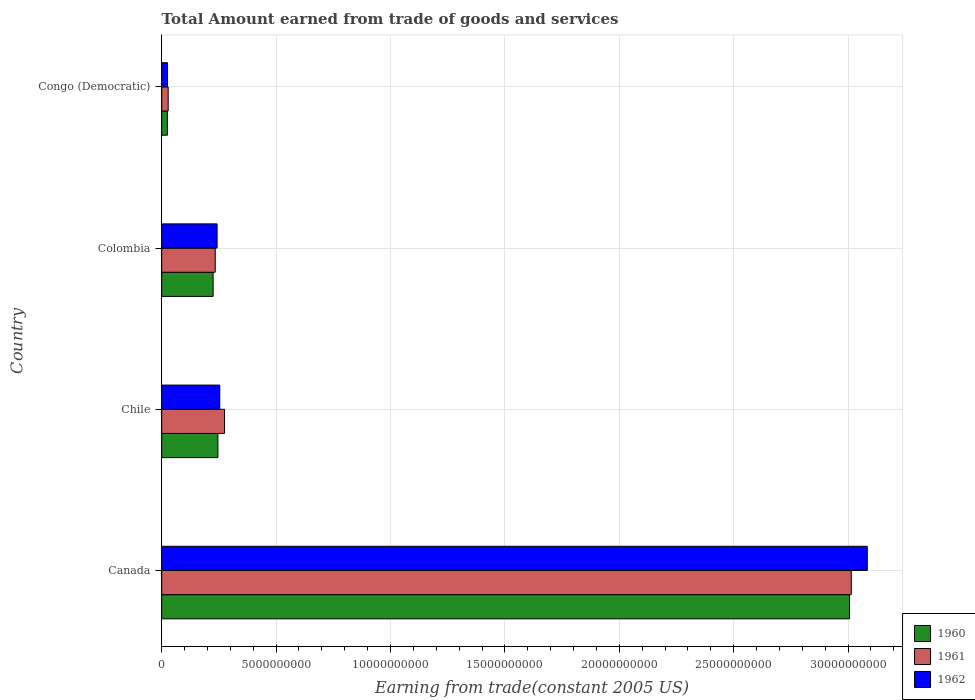Are the number of bars per tick equal to the number of legend labels?
Make the answer very short. Yes. How many bars are there on the 1st tick from the top?
Your response must be concise. 3. How many bars are there on the 2nd tick from the bottom?
Offer a very short reply. 3. In how many cases, is the number of bars for a given country not equal to the number of legend labels?
Give a very brief answer. 0. What is the total amount earned by trading goods and services in 1961 in Congo (Democratic)?
Offer a terse response. 2.83e+08. Across all countries, what is the maximum total amount earned by trading goods and services in 1960?
Your answer should be very brief. 3.01e+1. Across all countries, what is the minimum total amount earned by trading goods and services in 1961?
Keep it short and to the point. 2.83e+08. In which country was the total amount earned by trading goods and services in 1961 maximum?
Provide a succinct answer. Canada. In which country was the total amount earned by trading goods and services in 1962 minimum?
Keep it short and to the point. Congo (Democratic). What is the total total amount earned by trading goods and services in 1962 in the graph?
Offer a very short reply. 3.61e+1. What is the difference between the total amount earned by trading goods and services in 1960 in Colombia and that in Congo (Democratic)?
Offer a very short reply. 2.00e+09. What is the difference between the total amount earned by trading goods and services in 1961 in Chile and the total amount earned by trading goods and services in 1960 in Colombia?
Offer a terse response. 5.00e+08. What is the average total amount earned by trading goods and services in 1960 per country?
Provide a short and direct response. 8.75e+09. What is the difference between the total amount earned by trading goods and services in 1962 and total amount earned by trading goods and services in 1960 in Colombia?
Keep it short and to the point. 1.75e+08. What is the ratio of the total amount earned by trading goods and services in 1961 in Canada to that in Colombia?
Keep it short and to the point. 12.88. Is the difference between the total amount earned by trading goods and services in 1962 in Canada and Chile greater than the difference between the total amount earned by trading goods and services in 1960 in Canada and Chile?
Ensure brevity in your answer.  Yes. What is the difference between the highest and the second highest total amount earned by trading goods and services in 1961?
Offer a very short reply. 2.74e+1. What is the difference between the highest and the lowest total amount earned by trading goods and services in 1962?
Your answer should be very brief. 3.06e+1. What does the 2nd bar from the bottom in Colombia represents?
Offer a terse response. 1961. Is it the case that in every country, the sum of the total amount earned by trading goods and services in 1960 and total amount earned by trading goods and services in 1962 is greater than the total amount earned by trading goods and services in 1961?
Your answer should be compact. Yes. How many bars are there?
Make the answer very short. 12. Are all the bars in the graph horizontal?
Your answer should be very brief. Yes. How many countries are there in the graph?
Give a very brief answer. 4. Does the graph contain any zero values?
Ensure brevity in your answer.  No. Does the graph contain grids?
Provide a succinct answer. Yes. Where does the legend appear in the graph?
Keep it short and to the point. Bottom right. What is the title of the graph?
Offer a very short reply. Total Amount earned from trade of goods and services. Does "2006" appear as one of the legend labels in the graph?
Your response must be concise. No. What is the label or title of the X-axis?
Make the answer very short. Earning from trade(constant 2005 US). What is the Earning from trade(constant 2005 US) in 1960 in Canada?
Your answer should be compact. 3.01e+1. What is the Earning from trade(constant 2005 US) of 1961 in Canada?
Ensure brevity in your answer.  3.01e+1. What is the Earning from trade(constant 2005 US) of 1962 in Canada?
Keep it short and to the point. 3.08e+1. What is the Earning from trade(constant 2005 US) in 1960 in Chile?
Your answer should be compact. 2.46e+09. What is the Earning from trade(constant 2005 US) of 1961 in Chile?
Provide a short and direct response. 2.75e+09. What is the Earning from trade(constant 2005 US) in 1962 in Chile?
Make the answer very short. 2.54e+09. What is the Earning from trade(constant 2005 US) in 1960 in Colombia?
Your answer should be very brief. 2.25e+09. What is the Earning from trade(constant 2005 US) in 1961 in Colombia?
Offer a terse response. 2.34e+09. What is the Earning from trade(constant 2005 US) of 1962 in Colombia?
Provide a short and direct response. 2.42e+09. What is the Earning from trade(constant 2005 US) of 1960 in Congo (Democratic)?
Offer a terse response. 2.48e+08. What is the Earning from trade(constant 2005 US) of 1961 in Congo (Democratic)?
Ensure brevity in your answer.  2.83e+08. What is the Earning from trade(constant 2005 US) in 1962 in Congo (Democratic)?
Provide a succinct answer. 2.54e+08. Across all countries, what is the maximum Earning from trade(constant 2005 US) of 1960?
Your response must be concise. 3.01e+1. Across all countries, what is the maximum Earning from trade(constant 2005 US) of 1961?
Your answer should be compact. 3.01e+1. Across all countries, what is the maximum Earning from trade(constant 2005 US) in 1962?
Offer a terse response. 3.08e+1. Across all countries, what is the minimum Earning from trade(constant 2005 US) of 1960?
Offer a terse response. 2.48e+08. Across all countries, what is the minimum Earning from trade(constant 2005 US) of 1961?
Your answer should be very brief. 2.83e+08. Across all countries, what is the minimum Earning from trade(constant 2005 US) in 1962?
Make the answer very short. 2.54e+08. What is the total Earning from trade(constant 2005 US) in 1960 in the graph?
Offer a very short reply. 3.50e+1. What is the total Earning from trade(constant 2005 US) of 1961 in the graph?
Your response must be concise. 3.55e+1. What is the total Earning from trade(constant 2005 US) of 1962 in the graph?
Offer a very short reply. 3.61e+1. What is the difference between the Earning from trade(constant 2005 US) of 1960 in Canada and that in Chile?
Offer a very short reply. 2.76e+1. What is the difference between the Earning from trade(constant 2005 US) of 1961 in Canada and that in Chile?
Offer a terse response. 2.74e+1. What is the difference between the Earning from trade(constant 2005 US) in 1962 in Canada and that in Chile?
Give a very brief answer. 2.83e+1. What is the difference between the Earning from trade(constant 2005 US) in 1960 in Canada and that in Colombia?
Your response must be concise. 2.78e+1. What is the difference between the Earning from trade(constant 2005 US) of 1961 in Canada and that in Colombia?
Make the answer very short. 2.78e+1. What is the difference between the Earning from trade(constant 2005 US) of 1962 in Canada and that in Colombia?
Offer a very short reply. 2.84e+1. What is the difference between the Earning from trade(constant 2005 US) of 1960 in Canada and that in Congo (Democratic)?
Give a very brief answer. 2.98e+1. What is the difference between the Earning from trade(constant 2005 US) in 1961 in Canada and that in Congo (Democratic)?
Offer a very short reply. 2.99e+1. What is the difference between the Earning from trade(constant 2005 US) of 1962 in Canada and that in Congo (Democratic)?
Provide a succinct answer. 3.06e+1. What is the difference between the Earning from trade(constant 2005 US) of 1960 in Chile and that in Colombia?
Give a very brief answer. 2.10e+08. What is the difference between the Earning from trade(constant 2005 US) in 1961 in Chile and that in Colombia?
Keep it short and to the point. 4.07e+08. What is the difference between the Earning from trade(constant 2005 US) of 1962 in Chile and that in Colombia?
Provide a short and direct response. 1.17e+08. What is the difference between the Earning from trade(constant 2005 US) in 1960 in Chile and that in Congo (Democratic)?
Provide a succinct answer. 2.21e+09. What is the difference between the Earning from trade(constant 2005 US) of 1961 in Chile and that in Congo (Democratic)?
Offer a very short reply. 2.46e+09. What is the difference between the Earning from trade(constant 2005 US) in 1962 in Chile and that in Congo (Democratic)?
Ensure brevity in your answer.  2.28e+09. What is the difference between the Earning from trade(constant 2005 US) in 1960 in Colombia and that in Congo (Democratic)?
Offer a very short reply. 2.00e+09. What is the difference between the Earning from trade(constant 2005 US) of 1961 in Colombia and that in Congo (Democratic)?
Your answer should be compact. 2.06e+09. What is the difference between the Earning from trade(constant 2005 US) of 1962 in Colombia and that in Congo (Democratic)?
Your response must be concise. 2.17e+09. What is the difference between the Earning from trade(constant 2005 US) in 1960 in Canada and the Earning from trade(constant 2005 US) in 1961 in Chile?
Make the answer very short. 2.73e+1. What is the difference between the Earning from trade(constant 2005 US) in 1960 in Canada and the Earning from trade(constant 2005 US) in 1962 in Chile?
Provide a short and direct response. 2.75e+1. What is the difference between the Earning from trade(constant 2005 US) in 1961 in Canada and the Earning from trade(constant 2005 US) in 1962 in Chile?
Provide a succinct answer. 2.76e+1. What is the difference between the Earning from trade(constant 2005 US) in 1960 in Canada and the Earning from trade(constant 2005 US) in 1961 in Colombia?
Your answer should be very brief. 2.77e+1. What is the difference between the Earning from trade(constant 2005 US) of 1960 in Canada and the Earning from trade(constant 2005 US) of 1962 in Colombia?
Your answer should be very brief. 2.76e+1. What is the difference between the Earning from trade(constant 2005 US) of 1961 in Canada and the Earning from trade(constant 2005 US) of 1962 in Colombia?
Your answer should be very brief. 2.77e+1. What is the difference between the Earning from trade(constant 2005 US) in 1960 in Canada and the Earning from trade(constant 2005 US) in 1961 in Congo (Democratic)?
Your answer should be very brief. 2.98e+1. What is the difference between the Earning from trade(constant 2005 US) of 1960 in Canada and the Earning from trade(constant 2005 US) of 1962 in Congo (Democratic)?
Provide a succinct answer. 2.98e+1. What is the difference between the Earning from trade(constant 2005 US) of 1961 in Canada and the Earning from trade(constant 2005 US) of 1962 in Congo (Democratic)?
Your answer should be very brief. 2.99e+1. What is the difference between the Earning from trade(constant 2005 US) of 1960 in Chile and the Earning from trade(constant 2005 US) of 1961 in Colombia?
Your answer should be very brief. 1.17e+08. What is the difference between the Earning from trade(constant 2005 US) of 1960 in Chile and the Earning from trade(constant 2005 US) of 1962 in Colombia?
Your response must be concise. 3.52e+07. What is the difference between the Earning from trade(constant 2005 US) in 1961 in Chile and the Earning from trade(constant 2005 US) in 1962 in Colombia?
Your response must be concise. 3.25e+08. What is the difference between the Earning from trade(constant 2005 US) of 1960 in Chile and the Earning from trade(constant 2005 US) of 1961 in Congo (Democratic)?
Ensure brevity in your answer.  2.17e+09. What is the difference between the Earning from trade(constant 2005 US) in 1960 in Chile and the Earning from trade(constant 2005 US) in 1962 in Congo (Democratic)?
Offer a very short reply. 2.20e+09. What is the difference between the Earning from trade(constant 2005 US) in 1961 in Chile and the Earning from trade(constant 2005 US) in 1962 in Congo (Democratic)?
Provide a succinct answer. 2.49e+09. What is the difference between the Earning from trade(constant 2005 US) in 1960 in Colombia and the Earning from trade(constant 2005 US) in 1961 in Congo (Democratic)?
Provide a succinct answer. 1.96e+09. What is the difference between the Earning from trade(constant 2005 US) of 1960 in Colombia and the Earning from trade(constant 2005 US) of 1962 in Congo (Democratic)?
Keep it short and to the point. 1.99e+09. What is the difference between the Earning from trade(constant 2005 US) in 1961 in Colombia and the Earning from trade(constant 2005 US) in 1962 in Congo (Democratic)?
Your answer should be very brief. 2.09e+09. What is the average Earning from trade(constant 2005 US) in 1960 per country?
Offer a very short reply. 8.75e+09. What is the average Earning from trade(constant 2005 US) of 1961 per country?
Make the answer very short. 8.88e+09. What is the average Earning from trade(constant 2005 US) of 1962 per country?
Make the answer very short. 9.01e+09. What is the difference between the Earning from trade(constant 2005 US) in 1960 and Earning from trade(constant 2005 US) in 1961 in Canada?
Offer a very short reply. -7.60e+07. What is the difference between the Earning from trade(constant 2005 US) in 1960 and Earning from trade(constant 2005 US) in 1962 in Canada?
Offer a very short reply. -7.75e+08. What is the difference between the Earning from trade(constant 2005 US) in 1961 and Earning from trade(constant 2005 US) in 1962 in Canada?
Offer a very short reply. -6.99e+08. What is the difference between the Earning from trade(constant 2005 US) of 1960 and Earning from trade(constant 2005 US) of 1961 in Chile?
Offer a very short reply. -2.90e+08. What is the difference between the Earning from trade(constant 2005 US) in 1960 and Earning from trade(constant 2005 US) in 1962 in Chile?
Your answer should be compact. -8.15e+07. What is the difference between the Earning from trade(constant 2005 US) in 1961 and Earning from trade(constant 2005 US) in 1962 in Chile?
Your answer should be very brief. 2.09e+08. What is the difference between the Earning from trade(constant 2005 US) in 1960 and Earning from trade(constant 2005 US) in 1961 in Colombia?
Make the answer very short. -9.33e+07. What is the difference between the Earning from trade(constant 2005 US) of 1960 and Earning from trade(constant 2005 US) of 1962 in Colombia?
Offer a very short reply. -1.75e+08. What is the difference between the Earning from trade(constant 2005 US) of 1961 and Earning from trade(constant 2005 US) of 1962 in Colombia?
Give a very brief answer. -8.16e+07. What is the difference between the Earning from trade(constant 2005 US) in 1960 and Earning from trade(constant 2005 US) in 1961 in Congo (Democratic)?
Provide a succinct answer. -3.54e+07. What is the difference between the Earning from trade(constant 2005 US) of 1960 and Earning from trade(constant 2005 US) of 1962 in Congo (Democratic)?
Provide a succinct answer. -6.61e+06. What is the difference between the Earning from trade(constant 2005 US) in 1961 and Earning from trade(constant 2005 US) in 1962 in Congo (Democratic)?
Make the answer very short. 2.88e+07. What is the ratio of the Earning from trade(constant 2005 US) in 1960 in Canada to that in Chile?
Give a very brief answer. 12.24. What is the ratio of the Earning from trade(constant 2005 US) of 1961 in Canada to that in Chile?
Your answer should be very brief. 10.97. What is the ratio of the Earning from trade(constant 2005 US) in 1962 in Canada to that in Chile?
Make the answer very short. 12.15. What is the ratio of the Earning from trade(constant 2005 US) in 1960 in Canada to that in Colombia?
Ensure brevity in your answer.  13.38. What is the ratio of the Earning from trade(constant 2005 US) of 1961 in Canada to that in Colombia?
Keep it short and to the point. 12.88. What is the ratio of the Earning from trade(constant 2005 US) of 1962 in Canada to that in Colombia?
Ensure brevity in your answer.  12.74. What is the ratio of the Earning from trade(constant 2005 US) of 1960 in Canada to that in Congo (Democratic)?
Keep it short and to the point. 121.4. What is the ratio of the Earning from trade(constant 2005 US) in 1961 in Canada to that in Congo (Democratic)?
Your answer should be very brief. 106.47. What is the ratio of the Earning from trade(constant 2005 US) of 1962 in Canada to that in Congo (Democratic)?
Offer a terse response. 121.29. What is the ratio of the Earning from trade(constant 2005 US) in 1960 in Chile to that in Colombia?
Give a very brief answer. 1.09. What is the ratio of the Earning from trade(constant 2005 US) in 1961 in Chile to that in Colombia?
Make the answer very short. 1.17. What is the ratio of the Earning from trade(constant 2005 US) of 1962 in Chile to that in Colombia?
Provide a short and direct response. 1.05. What is the ratio of the Earning from trade(constant 2005 US) of 1960 in Chile to that in Congo (Democratic)?
Provide a short and direct response. 9.92. What is the ratio of the Earning from trade(constant 2005 US) of 1961 in Chile to that in Congo (Democratic)?
Offer a very short reply. 9.7. What is the ratio of the Earning from trade(constant 2005 US) of 1962 in Chile to that in Congo (Democratic)?
Your answer should be very brief. 9.98. What is the ratio of the Earning from trade(constant 2005 US) in 1960 in Colombia to that in Congo (Democratic)?
Your answer should be very brief. 9.07. What is the ratio of the Earning from trade(constant 2005 US) of 1961 in Colombia to that in Congo (Democratic)?
Provide a short and direct response. 8.26. What is the ratio of the Earning from trade(constant 2005 US) of 1962 in Colombia to that in Congo (Democratic)?
Offer a terse response. 9.52. What is the difference between the highest and the second highest Earning from trade(constant 2005 US) of 1960?
Your answer should be compact. 2.76e+1. What is the difference between the highest and the second highest Earning from trade(constant 2005 US) in 1961?
Offer a terse response. 2.74e+1. What is the difference between the highest and the second highest Earning from trade(constant 2005 US) of 1962?
Offer a terse response. 2.83e+1. What is the difference between the highest and the lowest Earning from trade(constant 2005 US) in 1960?
Make the answer very short. 2.98e+1. What is the difference between the highest and the lowest Earning from trade(constant 2005 US) in 1961?
Your response must be concise. 2.99e+1. What is the difference between the highest and the lowest Earning from trade(constant 2005 US) in 1962?
Your answer should be very brief. 3.06e+1. 